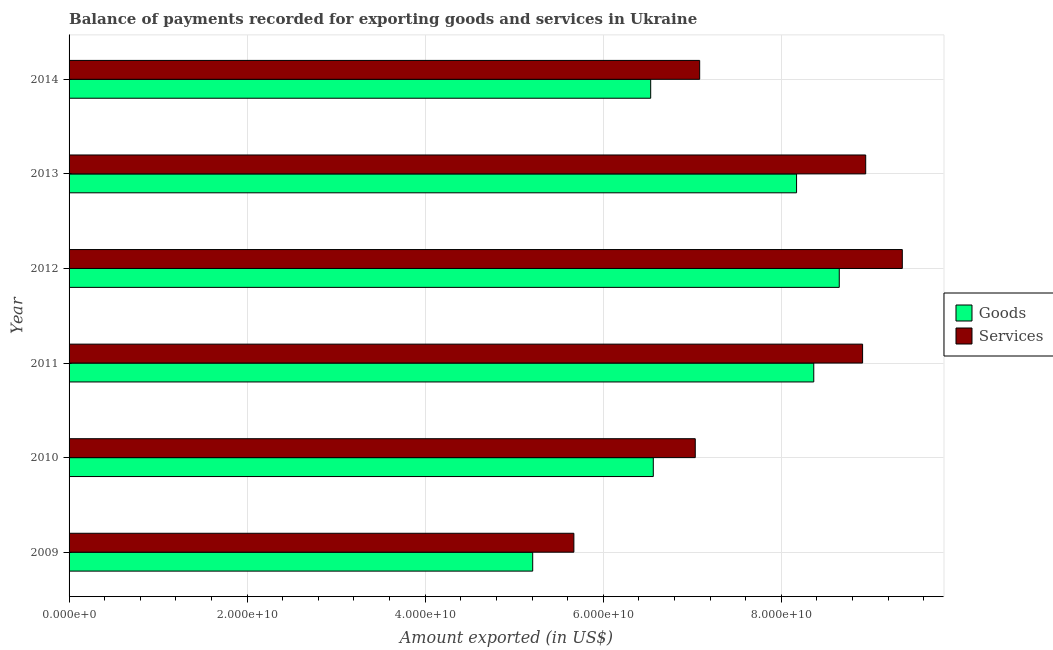How many different coloured bars are there?
Your response must be concise. 2. How many groups of bars are there?
Provide a succinct answer. 6. Are the number of bars per tick equal to the number of legend labels?
Give a very brief answer. Yes. How many bars are there on the 4th tick from the top?
Offer a very short reply. 2. How many bars are there on the 4th tick from the bottom?
Make the answer very short. 2. What is the amount of services exported in 2010?
Give a very brief answer. 7.03e+1. Across all years, what is the maximum amount of goods exported?
Your response must be concise. 8.65e+1. Across all years, what is the minimum amount of goods exported?
Provide a short and direct response. 5.21e+1. What is the total amount of goods exported in the graph?
Keep it short and to the point. 4.35e+11. What is the difference between the amount of goods exported in 2010 and that in 2011?
Provide a short and direct response. -1.80e+1. What is the difference between the amount of services exported in 2009 and the amount of goods exported in 2012?
Your answer should be compact. -2.98e+1. What is the average amount of services exported per year?
Provide a succinct answer. 7.84e+1. In the year 2014, what is the difference between the amount of services exported and amount of goods exported?
Make the answer very short. 5.50e+09. In how many years, is the amount of services exported greater than 4000000000 US$?
Offer a very short reply. 6. What is the ratio of the amount of goods exported in 2013 to that in 2014?
Offer a terse response. 1.25. Is the amount of goods exported in 2011 less than that in 2012?
Offer a terse response. Yes. Is the difference between the amount of services exported in 2009 and 2012 greater than the difference between the amount of goods exported in 2009 and 2012?
Ensure brevity in your answer.  No. What is the difference between the highest and the second highest amount of services exported?
Keep it short and to the point. 4.11e+09. What is the difference between the highest and the lowest amount of services exported?
Give a very brief answer. 3.69e+1. Is the sum of the amount of services exported in 2009 and 2013 greater than the maximum amount of goods exported across all years?
Keep it short and to the point. Yes. What does the 2nd bar from the top in 2010 represents?
Offer a terse response. Goods. What does the 1st bar from the bottom in 2011 represents?
Ensure brevity in your answer.  Goods. Are all the bars in the graph horizontal?
Offer a terse response. Yes. How many years are there in the graph?
Offer a very short reply. 6. Are the values on the major ticks of X-axis written in scientific E-notation?
Offer a very short reply. Yes. Does the graph contain grids?
Offer a very short reply. Yes. Where does the legend appear in the graph?
Make the answer very short. Center right. How are the legend labels stacked?
Offer a terse response. Vertical. What is the title of the graph?
Ensure brevity in your answer.  Balance of payments recorded for exporting goods and services in Ukraine. Does "Not attending school" appear as one of the legend labels in the graph?
Ensure brevity in your answer.  No. What is the label or title of the X-axis?
Your answer should be compact. Amount exported (in US$). What is the label or title of the Y-axis?
Provide a succinct answer. Year. What is the Amount exported (in US$) of Goods in 2009?
Offer a very short reply. 5.21e+1. What is the Amount exported (in US$) of Services in 2009?
Provide a short and direct response. 5.67e+1. What is the Amount exported (in US$) in Goods in 2010?
Make the answer very short. 6.56e+1. What is the Amount exported (in US$) in Services in 2010?
Make the answer very short. 7.03e+1. What is the Amount exported (in US$) in Goods in 2011?
Provide a succinct answer. 8.37e+1. What is the Amount exported (in US$) of Services in 2011?
Keep it short and to the point. 8.91e+1. What is the Amount exported (in US$) of Goods in 2012?
Ensure brevity in your answer.  8.65e+1. What is the Amount exported (in US$) of Services in 2012?
Your response must be concise. 9.36e+1. What is the Amount exported (in US$) in Goods in 2013?
Provide a succinct answer. 8.17e+1. What is the Amount exported (in US$) of Services in 2013?
Provide a short and direct response. 8.95e+1. What is the Amount exported (in US$) in Goods in 2014?
Your response must be concise. 6.53e+1. What is the Amount exported (in US$) of Services in 2014?
Ensure brevity in your answer.  7.08e+1. Across all years, what is the maximum Amount exported (in US$) of Goods?
Your answer should be compact. 8.65e+1. Across all years, what is the maximum Amount exported (in US$) of Services?
Ensure brevity in your answer.  9.36e+1. Across all years, what is the minimum Amount exported (in US$) in Goods?
Give a very brief answer. 5.21e+1. Across all years, what is the minimum Amount exported (in US$) of Services?
Your answer should be very brief. 5.67e+1. What is the total Amount exported (in US$) in Goods in the graph?
Ensure brevity in your answer.  4.35e+11. What is the total Amount exported (in US$) in Services in the graph?
Ensure brevity in your answer.  4.70e+11. What is the difference between the Amount exported (in US$) of Goods in 2009 and that in 2010?
Provide a succinct answer. -1.35e+1. What is the difference between the Amount exported (in US$) in Services in 2009 and that in 2010?
Your answer should be very brief. -1.36e+1. What is the difference between the Amount exported (in US$) of Goods in 2009 and that in 2011?
Provide a short and direct response. -3.16e+1. What is the difference between the Amount exported (in US$) of Services in 2009 and that in 2011?
Keep it short and to the point. -3.24e+1. What is the difference between the Amount exported (in US$) of Goods in 2009 and that in 2012?
Keep it short and to the point. -3.44e+1. What is the difference between the Amount exported (in US$) of Services in 2009 and that in 2012?
Ensure brevity in your answer.  -3.69e+1. What is the difference between the Amount exported (in US$) in Goods in 2009 and that in 2013?
Provide a short and direct response. -2.96e+1. What is the difference between the Amount exported (in US$) of Services in 2009 and that in 2013?
Give a very brief answer. -3.28e+1. What is the difference between the Amount exported (in US$) in Goods in 2009 and that in 2014?
Your response must be concise. -1.33e+1. What is the difference between the Amount exported (in US$) of Services in 2009 and that in 2014?
Offer a very short reply. -1.41e+1. What is the difference between the Amount exported (in US$) in Goods in 2010 and that in 2011?
Your answer should be very brief. -1.80e+1. What is the difference between the Amount exported (in US$) in Services in 2010 and that in 2011?
Offer a terse response. -1.88e+1. What is the difference between the Amount exported (in US$) of Goods in 2010 and that in 2012?
Provide a short and direct response. -2.09e+1. What is the difference between the Amount exported (in US$) in Services in 2010 and that in 2012?
Keep it short and to the point. -2.33e+1. What is the difference between the Amount exported (in US$) in Goods in 2010 and that in 2013?
Offer a terse response. -1.61e+1. What is the difference between the Amount exported (in US$) in Services in 2010 and that in 2013?
Your answer should be compact. -1.91e+1. What is the difference between the Amount exported (in US$) of Goods in 2010 and that in 2014?
Provide a succinct answer. 2.94e+08. What is the difference between the Amount exported (in US$) in Services in 2010 and that in 2014?
Give a very brief answer. -4.94e+08. What is the difference between the Amount exported (in US$) of Goods in 2011 and that in 2012?
Offer a very short reply. -2.86e+09. What is the difference between the Amount exported (in US$) in Services in 2011 and that in 2012?
Ensure brevity in your answer.  -4.46e+09. What is the difference between the Amount exported (in US$) of Goods in 2011 and that in 2013?
Make the answer very short. 1.93e+09. What is the difference between the Amount exported (in US$) in Services in 2011 and that in 2013?
Provide a succinct answer. -3.49e+08. What is the difference between the Amount exported (in US$) in Goods in 2011 and that in 2014?
Your answer should be compact. 1.83e+1. What is the difference between the Amount exported (in US$) in Services in 2011 and that in 2014?
Your answer should be very brief. 1.83e+1. What is the difference between the Amount exported (in US$) of Goods in 2012 and that in 2013?
Keep it short and to the point. 4.80e+09. What is the difference between the Amount exported (in US$) in Services in 2012 and that in 2013?
Ensure brevity in your answer.  4.11e+09. What is the difference between the Amount exported (in US$) of Goods in 2012 and that in 2014?
Ensure brevity in your answer.  2.12e+1. What is the difference between the Amount exported (in US$) in Services in 2012 and that in 2014?
Offer a very short reply. 2.28e+1. What is the difference between the Amount exported (in US$) in Goods in 2013 and that in 2014?
Your answer should be very brief. 1.64e+1. What is the difference between the Amount exported (in US$) of Services in 2013 and that in 2014?
Offer a terse response. 1.87e+1. What is the difference between the Amount exported (in US$) of Goods in 2009 and the Amount exported (in US$) of Services in 2010?
Offer a terse response. -1.83e+1. What is the difference between the Amount exported (in US$) of Goods in 2009 and the Amount exported (in US$) of Services in 2011?
Provide a short and direct response. -3.71e+1. What is the difference between the Amount exported (in US$) in Goods in 2009 and the Amount exported (in US$) in Services in 2012?
Give a very brief answer. -4.15e+1. What is the difference between the Amount exported (in US$) in Goods in 2009 and the Amount exported (in US$) in Services in 2013?
Provide a short and direct response. -3.74e+1. What is the difference between the Amount exported (in US$) in Goods in 2009 and the Amount exported (in US$) in Services in 2014?
Give a very brief answer. -1.88e+1. What is the difference between the Amount exported (in US$) of Goods in 2010 and the Amount exported (in US$) of Services in 2011?
Keep it short and to the point. -2.35e+1. What is the difference between the Amount exported (in US$) in Goods in 2010 and the Amount exported (in US$) in Services in 2012?
Your answer should be very brief. -2.80e+1. What is the difference between the Amount exported (in US$) of Goods in 2010 and the Amount exported (in US$) of Services in 2013?
Offer a terse response. -2.39e+1. What is the difference between the Amount exported (in US$) of Goods in 2010 and the Amount exported (in US$) of Services in 2014?
Your answer should be very brief. -5.21e+09. What is the difference between the Amount exported (in US$) of Goods in 2011 and the Amount exported (in US$) of Services in 2012?
Keep it short and to the point. -9.95e+09. What is the difference between the Amount exported (in US$) in Goods in 2011 and the Amount exported (in US$) in Services in 2013?
Give a very brief answer. -5.83e+09. What is the difference between the Amount exported (in US$) of Goods in 2011 and the Amount exported (in US$) of Services in 2014?
Your answer should be compact. 1.28e+1. What is the difference between the Amount exported (in US$) of Goods in 2012 and the Amount exported (in US$) of Services in 2013?
Your answer should be very brief. -2.97e+09. What is the difference between the Amount exported (in US$) in Goods in 2012 and the Amount exported (in US$) in Services in 2014?
Offer a very short reply. 1.57e+1. What is the difference between the Amount exported (in US$) of Goods in 2013 and the Amount exported (in US$) of Services in 2014?
Keep it short and to the point. 1.09e+1. What is the average Amount exported (in US$) in Goods per year?
Your answer should be very brief. 7.25e+1. What is the average Amount exported (in US$) in Services per year?
Provide a succinct answer. 7.84e+1. In the year 2009, what is the difference between the Amount exported (in US$) in Goods and Amount exported (in US$) in Services?
Your response must be concise. -4.62e+09. In the year 2010, what is the difference between the Amount exported (in US$) in Goods and Amount exported (in US$) in Services?
Offer a very short reply. -4.72e+09. In the year 2011, what is the difference between the Amount exported (in US$) of Goods and Amount exported (in US$) of Services?
Ensure brevity in your answer.  -5.48e+09. In the year 2012, what is the difference between the Amount exported (in US$) of Goods and Amount exported (in US$) of Services?
Your answer should be very brief. -7.08e+09. In the year 2013, what is the difference between the Amount exported (in US$) of Goods and Amount exported (in US$) of Services?
Keep it short and to the point. -7.77e+09. In the year 2014, what is the difference between the Amount exported (in US$) in Goods and Amount exported (in US$) in Services?
Your answer should be compact. -5.50e+09. What is the ratio of the Amount exported (in US$) in Goods in 2009 to that in 2010?
Your answer should be compact. 0.79. What is the ratio of the Amount exported (in US$) of Services in 2009 to that in 2010?
Offer a terse response. 0.81. What is the ratio of the Amount exported (in US$) in Goods in 2009 to that in 2011?
Your answer should be compact. 0.62. What is the ratio of the Amount exported (in US$) in Services in 2009 to that in 2011?
Offer a very short reply. 0.64. What is the ratio of the Amount exported (in US$) of Goods in 2009 to that in 2012?
Provide a succinct answer. 0.6. What is the ratio of the Amount exported (in US$) in Services in 2009 to that in 2012?
Keep it short and to the point. 0.61. What is the ratio of the Amount exported (in US$) in Goods in 2009 to that in 2013?
Ensure brevity in your answer.  0.64. What is the ratio of the Amount exported (in US$) of Services in 2009 to that in 2013?
Provide a succinct answer. 0.63. What is the ratio of the Amount exported (in US$) in Goods in 2009 to that in 2014?
Provide a short and direct response. 0.8. What is the ratio of the Amount exported (in US$) of Services in 2009 to that in 2014?
Keep it short and to the point. 0.8. What is the ratio of the Amount exported (in US$) in Goods in 2010 to that in 2011?
Your response must be concise. 0.78. What is the ratio of the Amount exported (in US$) of Services in 2010 to that in 2011?
Give a very brief answer. 0.79. What is the ratio of the Amount exported (in US$) of Goods in 2010 to that in 2012?
Make the answer very short. 0.76. What is the ratio of the Amount exported (in US$) in Services in 2010 to that in 2012?
Keep it short and to the point. 0.75. What is the ratio of the Amount exported (in US$) in Goods in 2010 to that in 2013?
Give a very brief answer. 0.8. What is the ratio of the Amount exported (in US$) in Services in 2010 to that in 2013?
Make the answer very short. 0.79. What is the ratio of the Amount exported (in US$) in Services in 2010 to that in 2014?
Give a very brief answer. 0.99. What is the ratio of the Amount exported (in US$) of Goods in 2011 to that in 2012?
Your answer should be very brief. 0.97. What is the ratio of the Amount exported (in US$) of Services in 2011 to that in 2012?
Provide a succinct answer. 0.95. What is the ratio of the Amount exported (in US$) of Goods in 2011 to that in 2013?
Your response must be concise. 1.02. What is the ratio of the Amount exported (in US$) of Services in 2011 to that in 2013?
Give a very brief answer. 1. What is the ratio of the Amount exported (in US$) of Goods in 2011 to that in 2014?
Provide a succinct answer. 1.28. What is the ratio of the Amount exported (in US$) of Services in 2011 to that in 2014?
Ensure brevity in your answer.  1.26. What is the ratio of the Amount exported (in US$) in Goods in 2012 to that in 2013?
Give a very brief answer. 1.06. What is the ratio of the Amount exported (in US$) in Services in 2012 to that in 2013?
Give a very brief answer. 1.05. What is the ratio of the Amount exported (in US$) in Goods in 2012 to that in 2014?
Provide a short and direct response. 1.32. What is the ratio of the Amount exported (in US$) in Services in 2012 to that in 2014?
Your answer should be very brief. 1.32. What is the ratio of the Amount exported (in US$) of Goods in 2013 to that in 2014?
Your answer should be compact. 1.25. What is the ratio of the Amount exported (in US$) of Services in 2013 to that in 2014?
Provide a succinct answer. 1.26. What is the difference between the highest and the second highest Amount exported (in US$) of Goods?
Ensure brevity in your answer.  2.86e+09. What is the difference between the highest and the second highest Amount exported (in US$) of Services?
Give a very brief answer. 4.11e+09. What is the difference between the highest and the lowest Amount exported (in US$) in Goods?
Ensure brevity in your answer.  3.44e+1. What is the difference between the highest and the lowest Amount exported (in US$) of Services?
Give a very brief answer. 3.69e+1. 